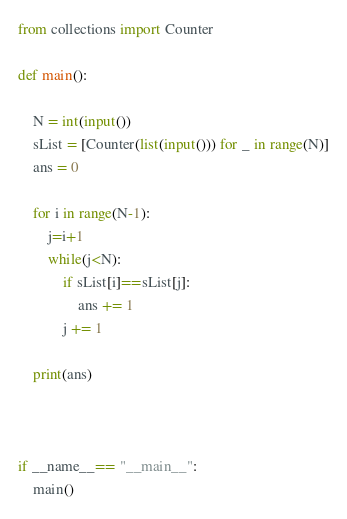Convert code to text. <code><loc_0><loc_0><loc_500><loc_500><_Python_>from collections import Counter

def main():

    N = int(input())
    sList = [Counter(list(input())) for _ in range(N)]
    ans = 0

    for i in range(N-1):
        j=i+1
        while(j<N):
            if sList[i]==sList[j]:
                ans += 1
            j += 1

    print(ans)


    
if __name__== "__main__":
    main() 









</code> 